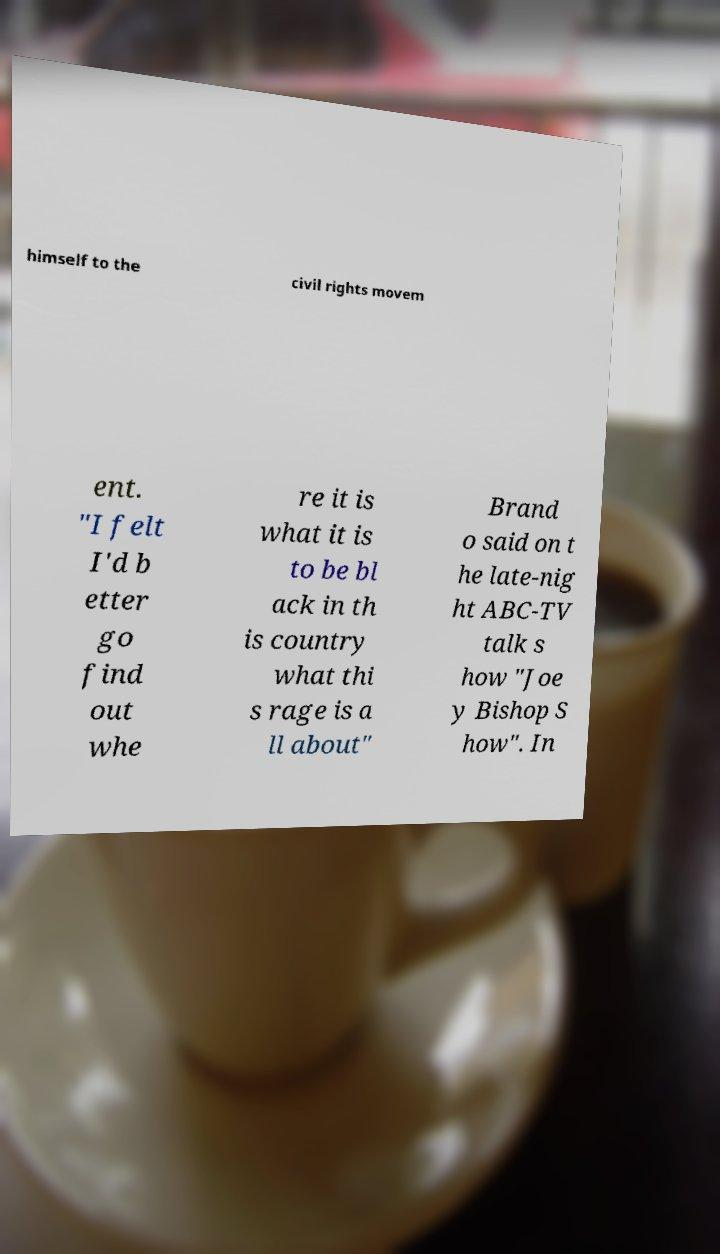Could you extract and type out the text from this image? himself to the civil rights movem ent. "I felt I'd b etter go find out whe re it is what it is to be bl ack in th is country what thi s rage is a ll about" Brand o said on t he late-nig ht ABC-TV talk s how "Joe y Bishop S how". In 